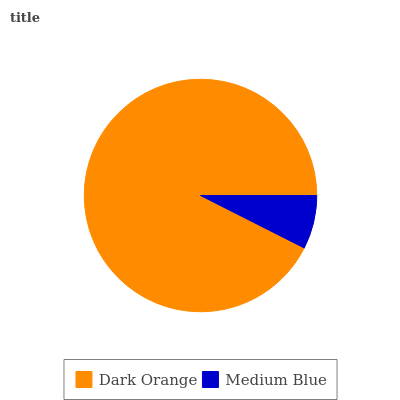Is Medium Blue the minimum?
Answer yes or no. Yes. Is Dark Orange the maximum?
Answer yes or no. Yes. Is Medium Blue the maximum?
Answer yes or no. No. Is Dark Orange greater than Medium Blue?
Answer yes or no. Yes. Is Medium Blue less than Dark Orange?
Answer yes or no. Yes. Is Medium Blue greater than Dark Orange?
Answer yes or no. No. Is Dark Orange less than Medium Blue?
Answer yes or no. No. Is Dark Orange the high median?
Answer yes or no. Yes. Is Medium Blue the low median?
Answer yes or no. Yes. Is Medium Blue the high median?
Answer yes or no. No. Is Dark Orange the low median?
Answer yes or no. No. 